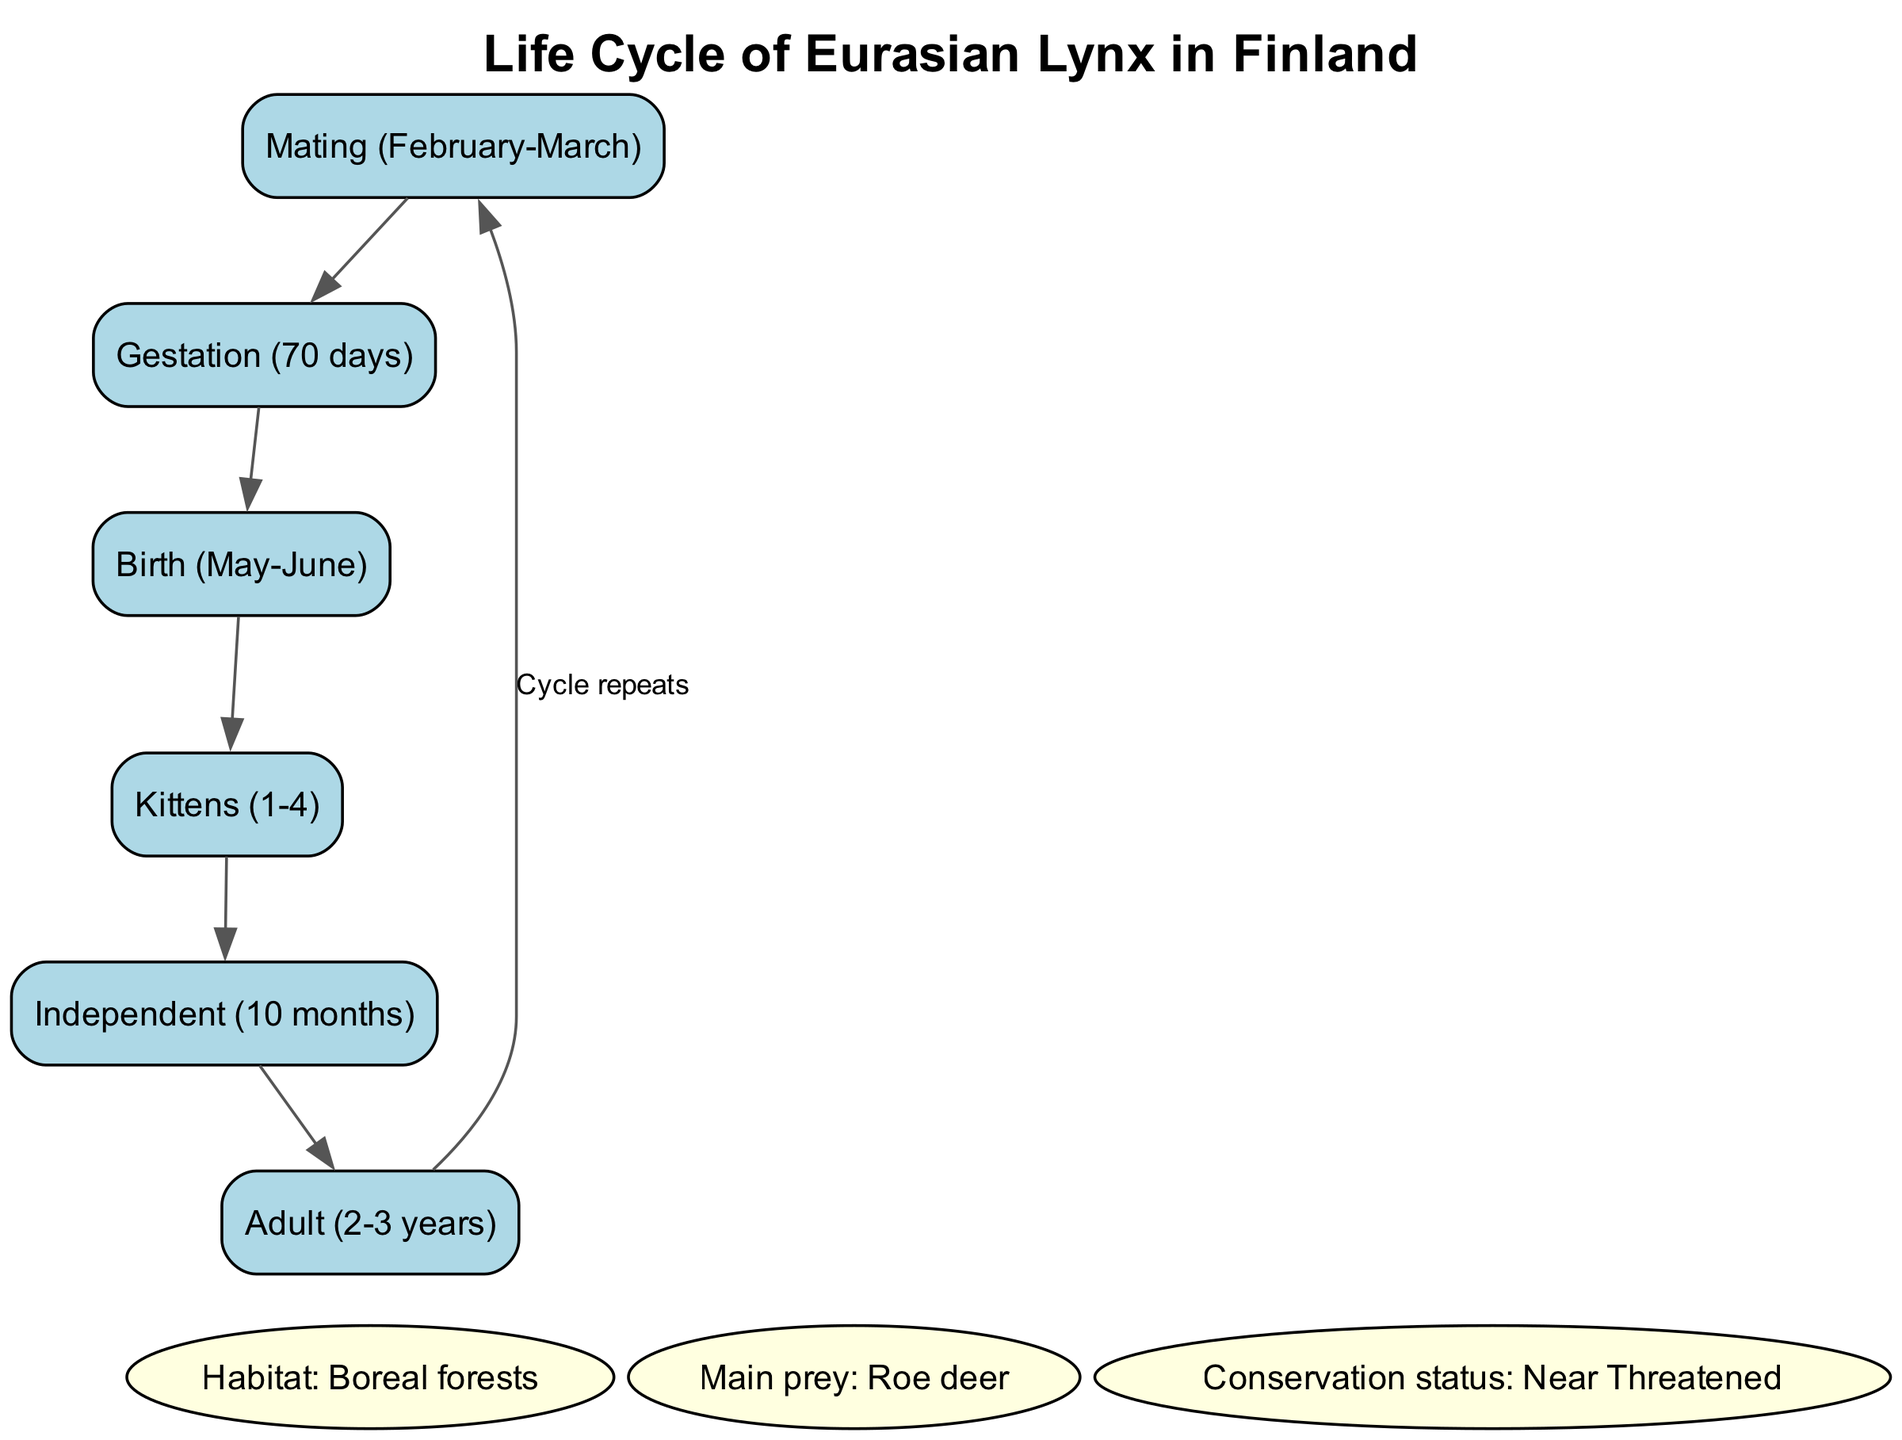What month does mating occur? According to the diagram, mating for the Eurasian lynx occurs in February and March, as indicated in the node labeled "Mating (February-March)."
Answer: February, March How long is the gestation period? The diagram specifies that the gestation period for the Eurasian lynx is 70 days, as indicated in the node labeled "Gestation (70 days)."
Answer: 70 days What is the main prey of the Eurasian lynx? The diagram shows that the main prey of the Eurasian lynx is roe deer, as indicated in the node labeled "Main prey: Roe deer."
Answer: Roe deer How many kittens can be born at a time? The diagram states that the Eurasian lynx can have between 1 to 4 kittens, as indicated in the node labeled "Kittens (1-4)."
Answer: 1-4 What is the conservation status of the Eurasian lynx in Finland? The diagram indicates that the conservation status of the Eurasian lynx in Finland is "Near Threatened," as noted in the node labeled "Conservation status: Near Threatened."
Answer: Near Threatened At what age do lynx become independent? According to the diagram, Eurasian lynx kittens become independent at 10 months of age, as indicated in the node labeled "Independent (10 months)."
Answer: 10 months How does the life cycle of the Eurasian lynx progress after the birth of the kittens? The flow in the diagram shows that after kittens are born, they grow until they are independent at 10 months, and then they become adults at 2-3 years, repeating the cycle from mating.
Answer: Mating to Independent (10 months) What habitat is suitable for the Eurasian lynx? The diagram specifies that the habitat of the Eurasian lynx is boreal forests, as shown in the node labeled "Habitat: Boreal forests."
Answer: Boreal forests How many nodes related to the life cycle are there in the diagram? Counting the nodes related to the life cycle: Mating, Gestation, Birth, Kittens, Independent, and Adult (totaling 5 nodes) indicates the focus on the life cycle specifically in this diagram.
Answer: 5 